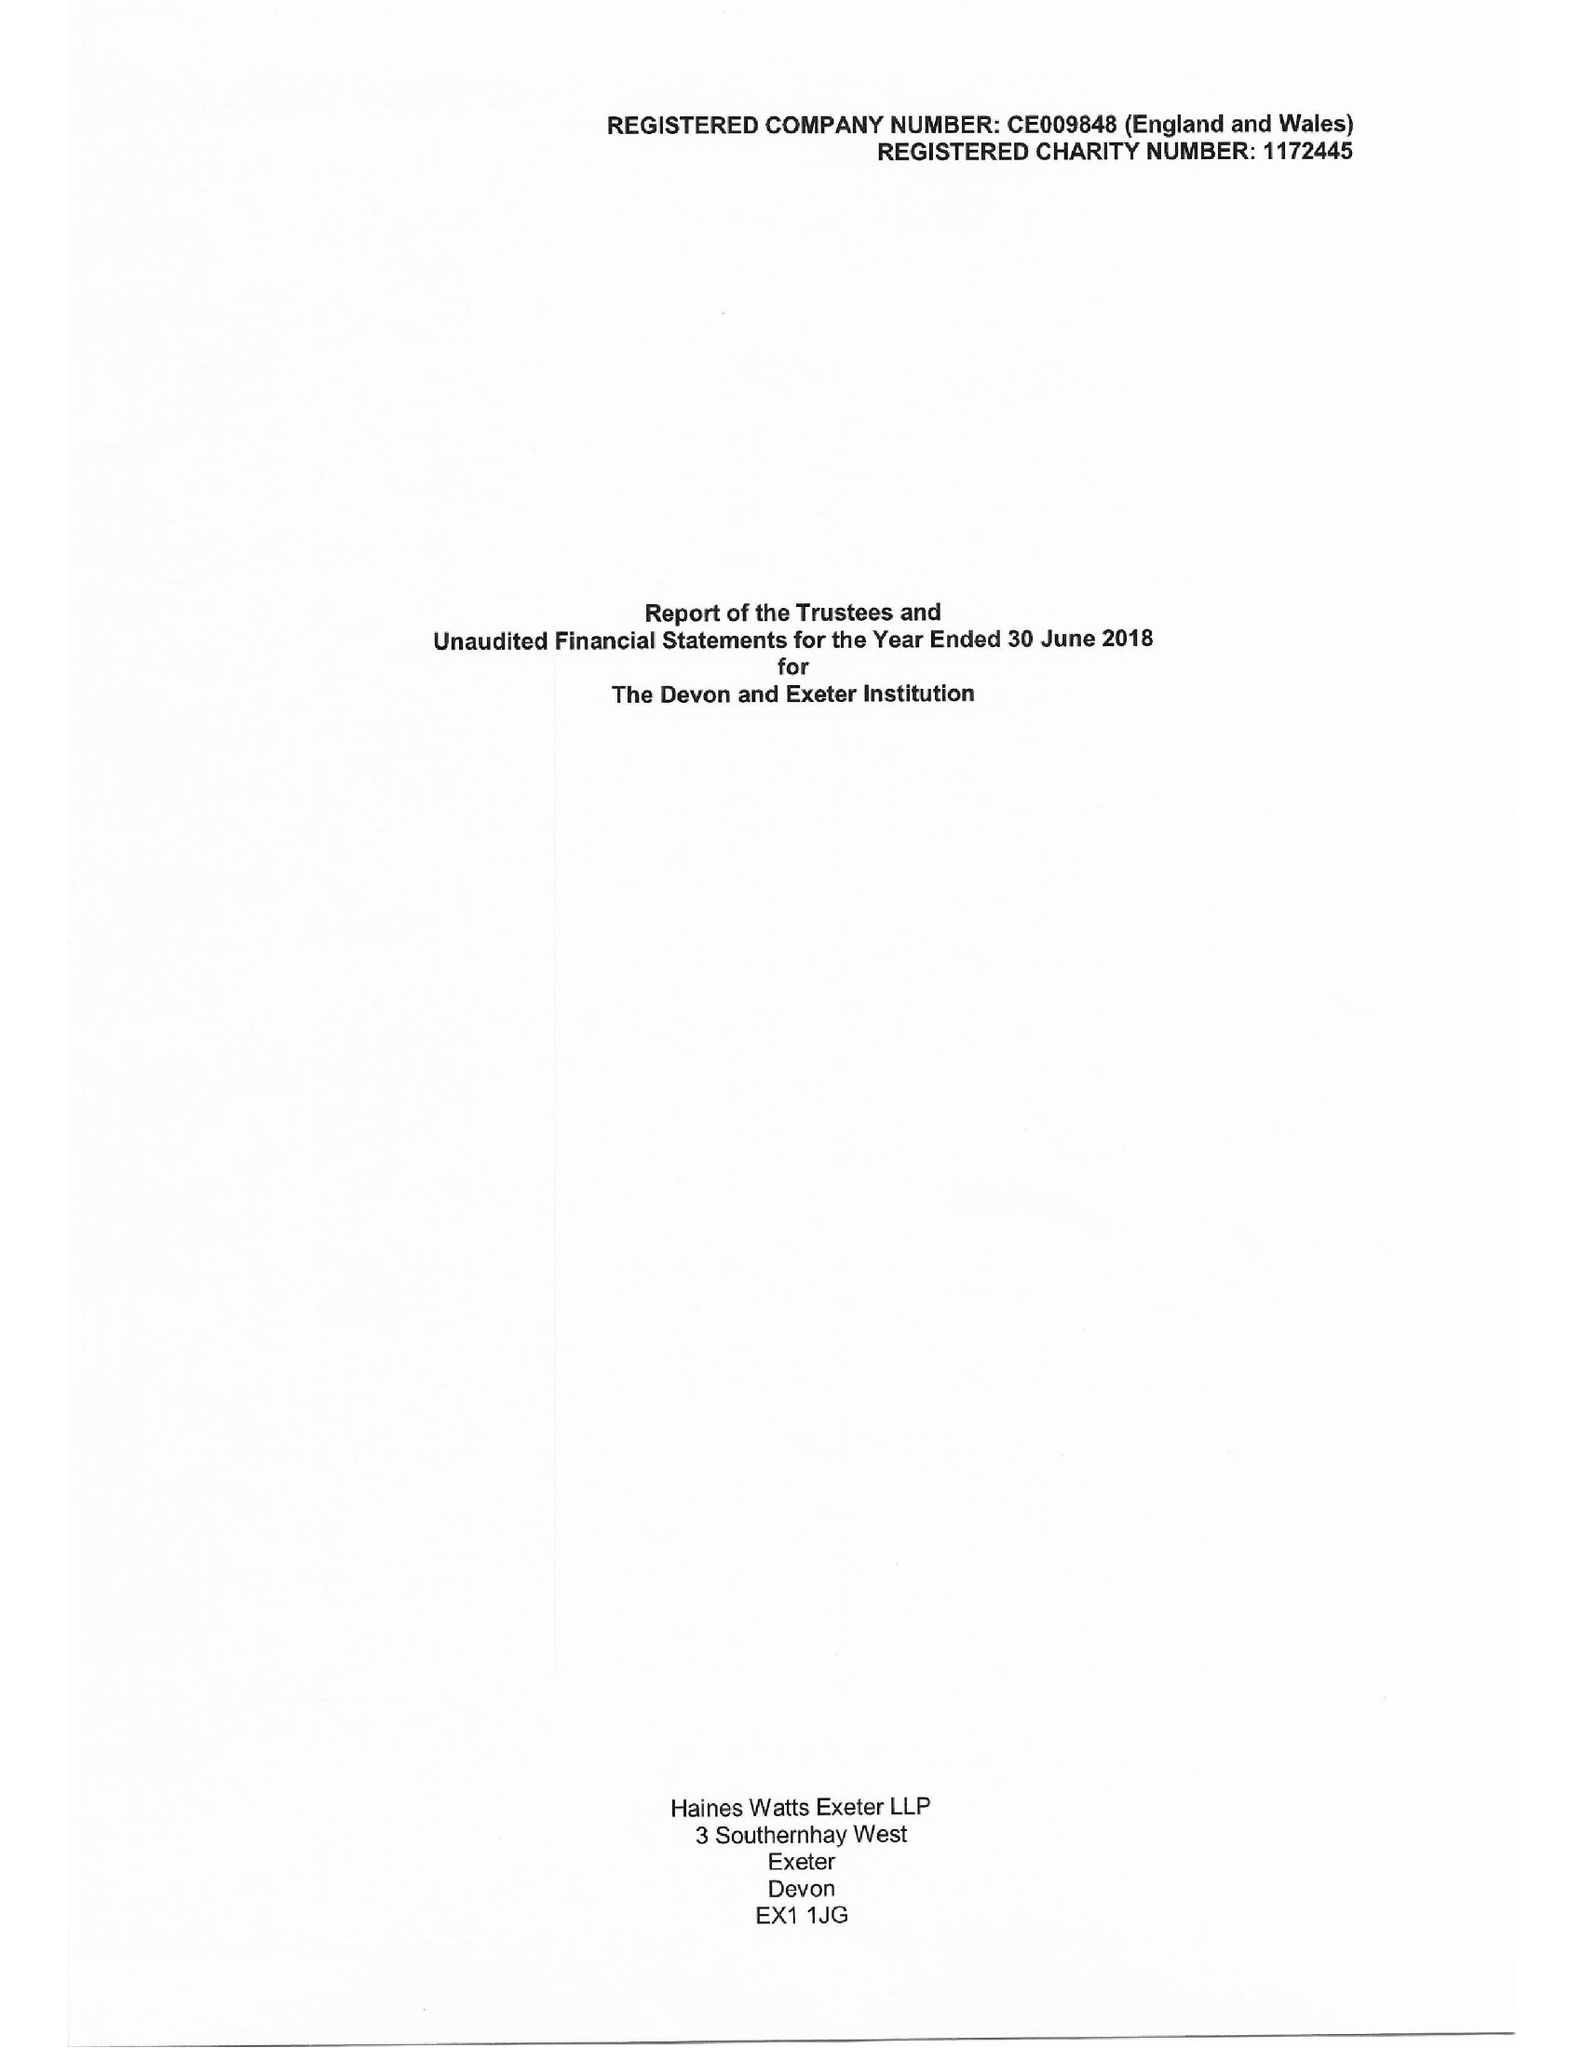What is the value for the address__postcode?
Answer the question using a single word or phrase. EX1 1EZ 